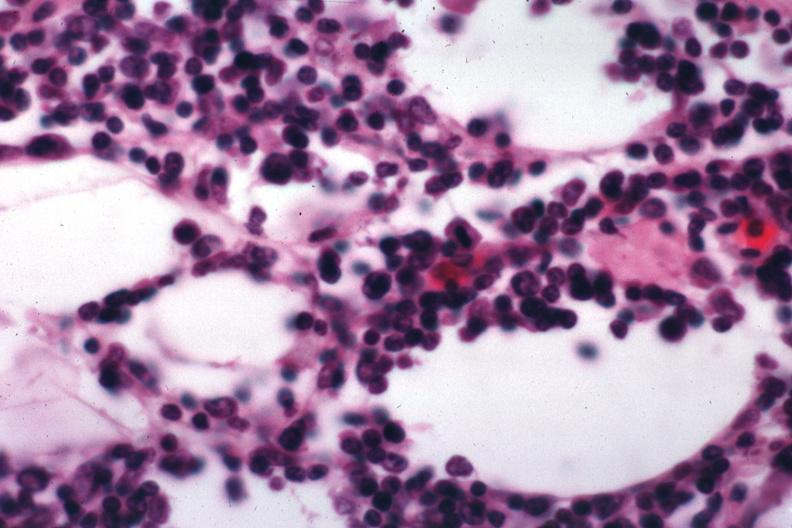s omentum present?
Answer the question using a single word or phrase. No 